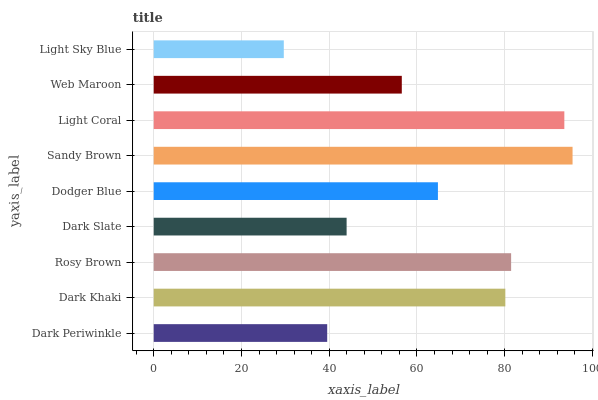Is Light Sky Blue the minimum?
Answer yes or no. Yes. Is Sandy Brown the maximum?
Answer yes or no. Yes. Is Dark Khaki the minimum?
Answer yes or no. No. Is Dark Khaki the maximum?
Answer yes or no. No. Is Dark Khaki greater than Dark Periwinkle?
Answer yes or no. Yes. Is Dark Periwinkle less than Dark Khaki?
Answer yes or no. Yes. Is Dark Periwinkle greater than Dark Khaki?
Answer yes or no. No. Is Dark Khaki less than Dark Periwinkle?
Answer yes or no. No. Is Dodger Blue the high median?
Answer yes or no. Yes. Is Dodger Blue the low median?
Answer yes or no. Yes. Is Light Coral the high median?
Answer yes or no. No. Is Light Sky Blue the low median?
Answer yes or no. No. 